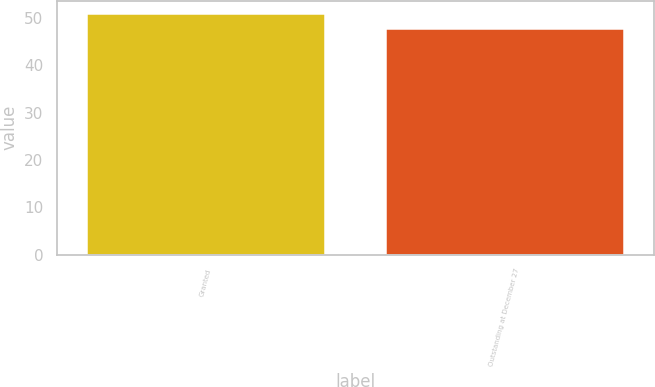<chart> <loc_0><loc_0><loc_500><loc_500><bar_chart><fcel>Granted<fcel>Outstanding at December 27<nl><fcel>51<fcel>47.76<nl></chart> 